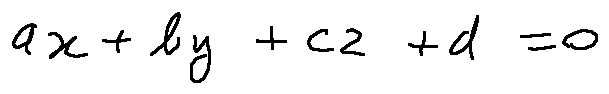<formula> <loc_0><loc_0><loc_500><loc_500>a x + b y + c z + d = 0</formula> 